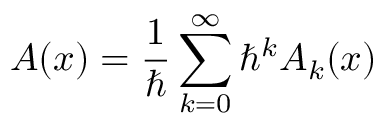Convert formula to latex. <formula><loc_0><loc_0><loc_500><loc_500>A ( x ) = { \frac { 1 } { } } \sum _ { k = 0 } ^ { \infty } \hbar { ^ } { k } A _ { k } ( x )</formula> 